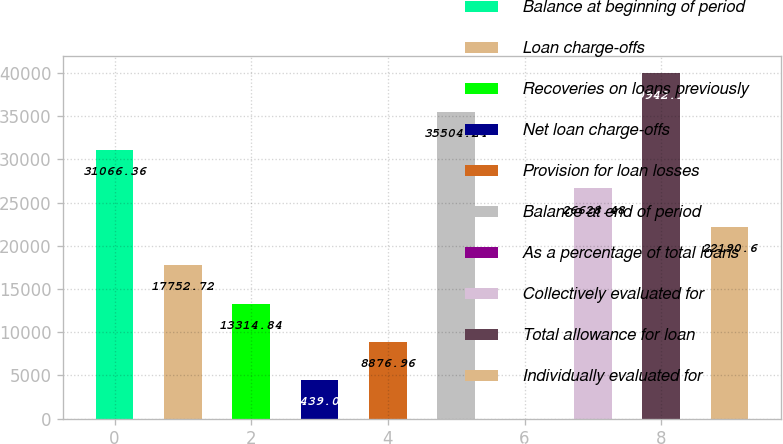Convert chart to OTSL. <chart><loc_0><loc_0><loc_500><loc_500><bar_chart><fcel>Balance at beginning of period<fcel>Loan charge-offs<fcel>Recoveries on loans previously<fcel>Net loan charge-offs<fcel>Provision for loan losses<fcel>Balance at end of period<fcel>As a percentage of total loans<fcel>Collectively evaluated for<fcel>Total allowance for loan<fcel>Individually evaluated for<nl><fcel>31066.4<fcel>17752.7<fcel>13314.8<fcel>4439.08<fcel>8876.96<fcel>35504.2<fcel>1.2<fcel>26628.5<fcel>39942.1<fcel>22190.6<nl></chart> 